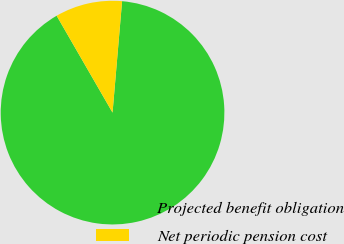<chart> <loc_0><loc_0><loc_500><loc_500><pie_chart><fcel>Projected benefit obligation<fcel>Net periodic pension cost<nl><fcel>90.31%<fcel>9.69%<nl></chart> 